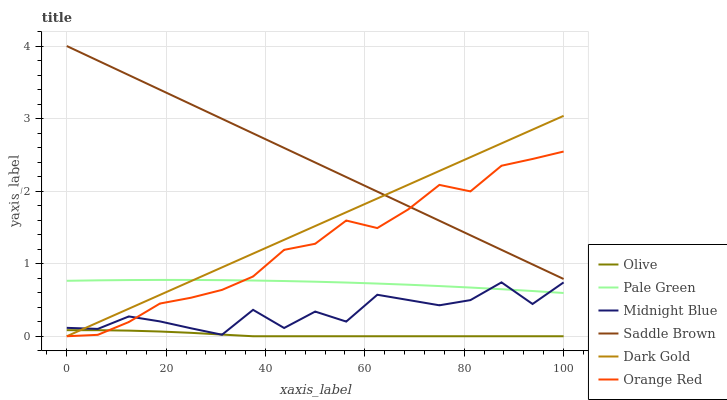Does Olive have the minimum area under the curve?
Answer yes or no. Yes. Does Saddle Brown have the maximum area under the curve?
Answer yes or no. Yes. Does Dark Gold have the minimum area under the curve?
Answer yes or no. No. Does Dark Gold have the maximum area under the curve?
Answer yes or no. No. Is Dark Gold the smoothest?
Answer yes or no. Yes. Is Midnight Blue the roughest?
Answer yes or no. Yes. Is Saddle Brown the smoothest?
Answer yes or no. No. Is Saddle Brown the roughest?
Answer yes or no. No. Does Dark Gold have the lowest value?
Answer yes or no. Yes. Does Saddle Brown have the lowest value?
Answer yes or no. No. Does Saddle Brown have the highest value?
Answer yes or no. Yes. Does Dark Gold have the highest value?
Answer yes or no. No. Is Olive less than Pale Green?
Answer yes or no. Yes. Is Pale Green greater than Olive?
Answer yes or no. Yes. Does Midnight Blue intersect Orange Red?
Answer yes or no. Yes. Is Midnight Blue less than Orange Red?
Answer yes or no. No. Is Midnight Blue greater than Orange Red?
Answer yes or no. No. Does Olive intersect Pale Green?
Answer yes or no. No. 